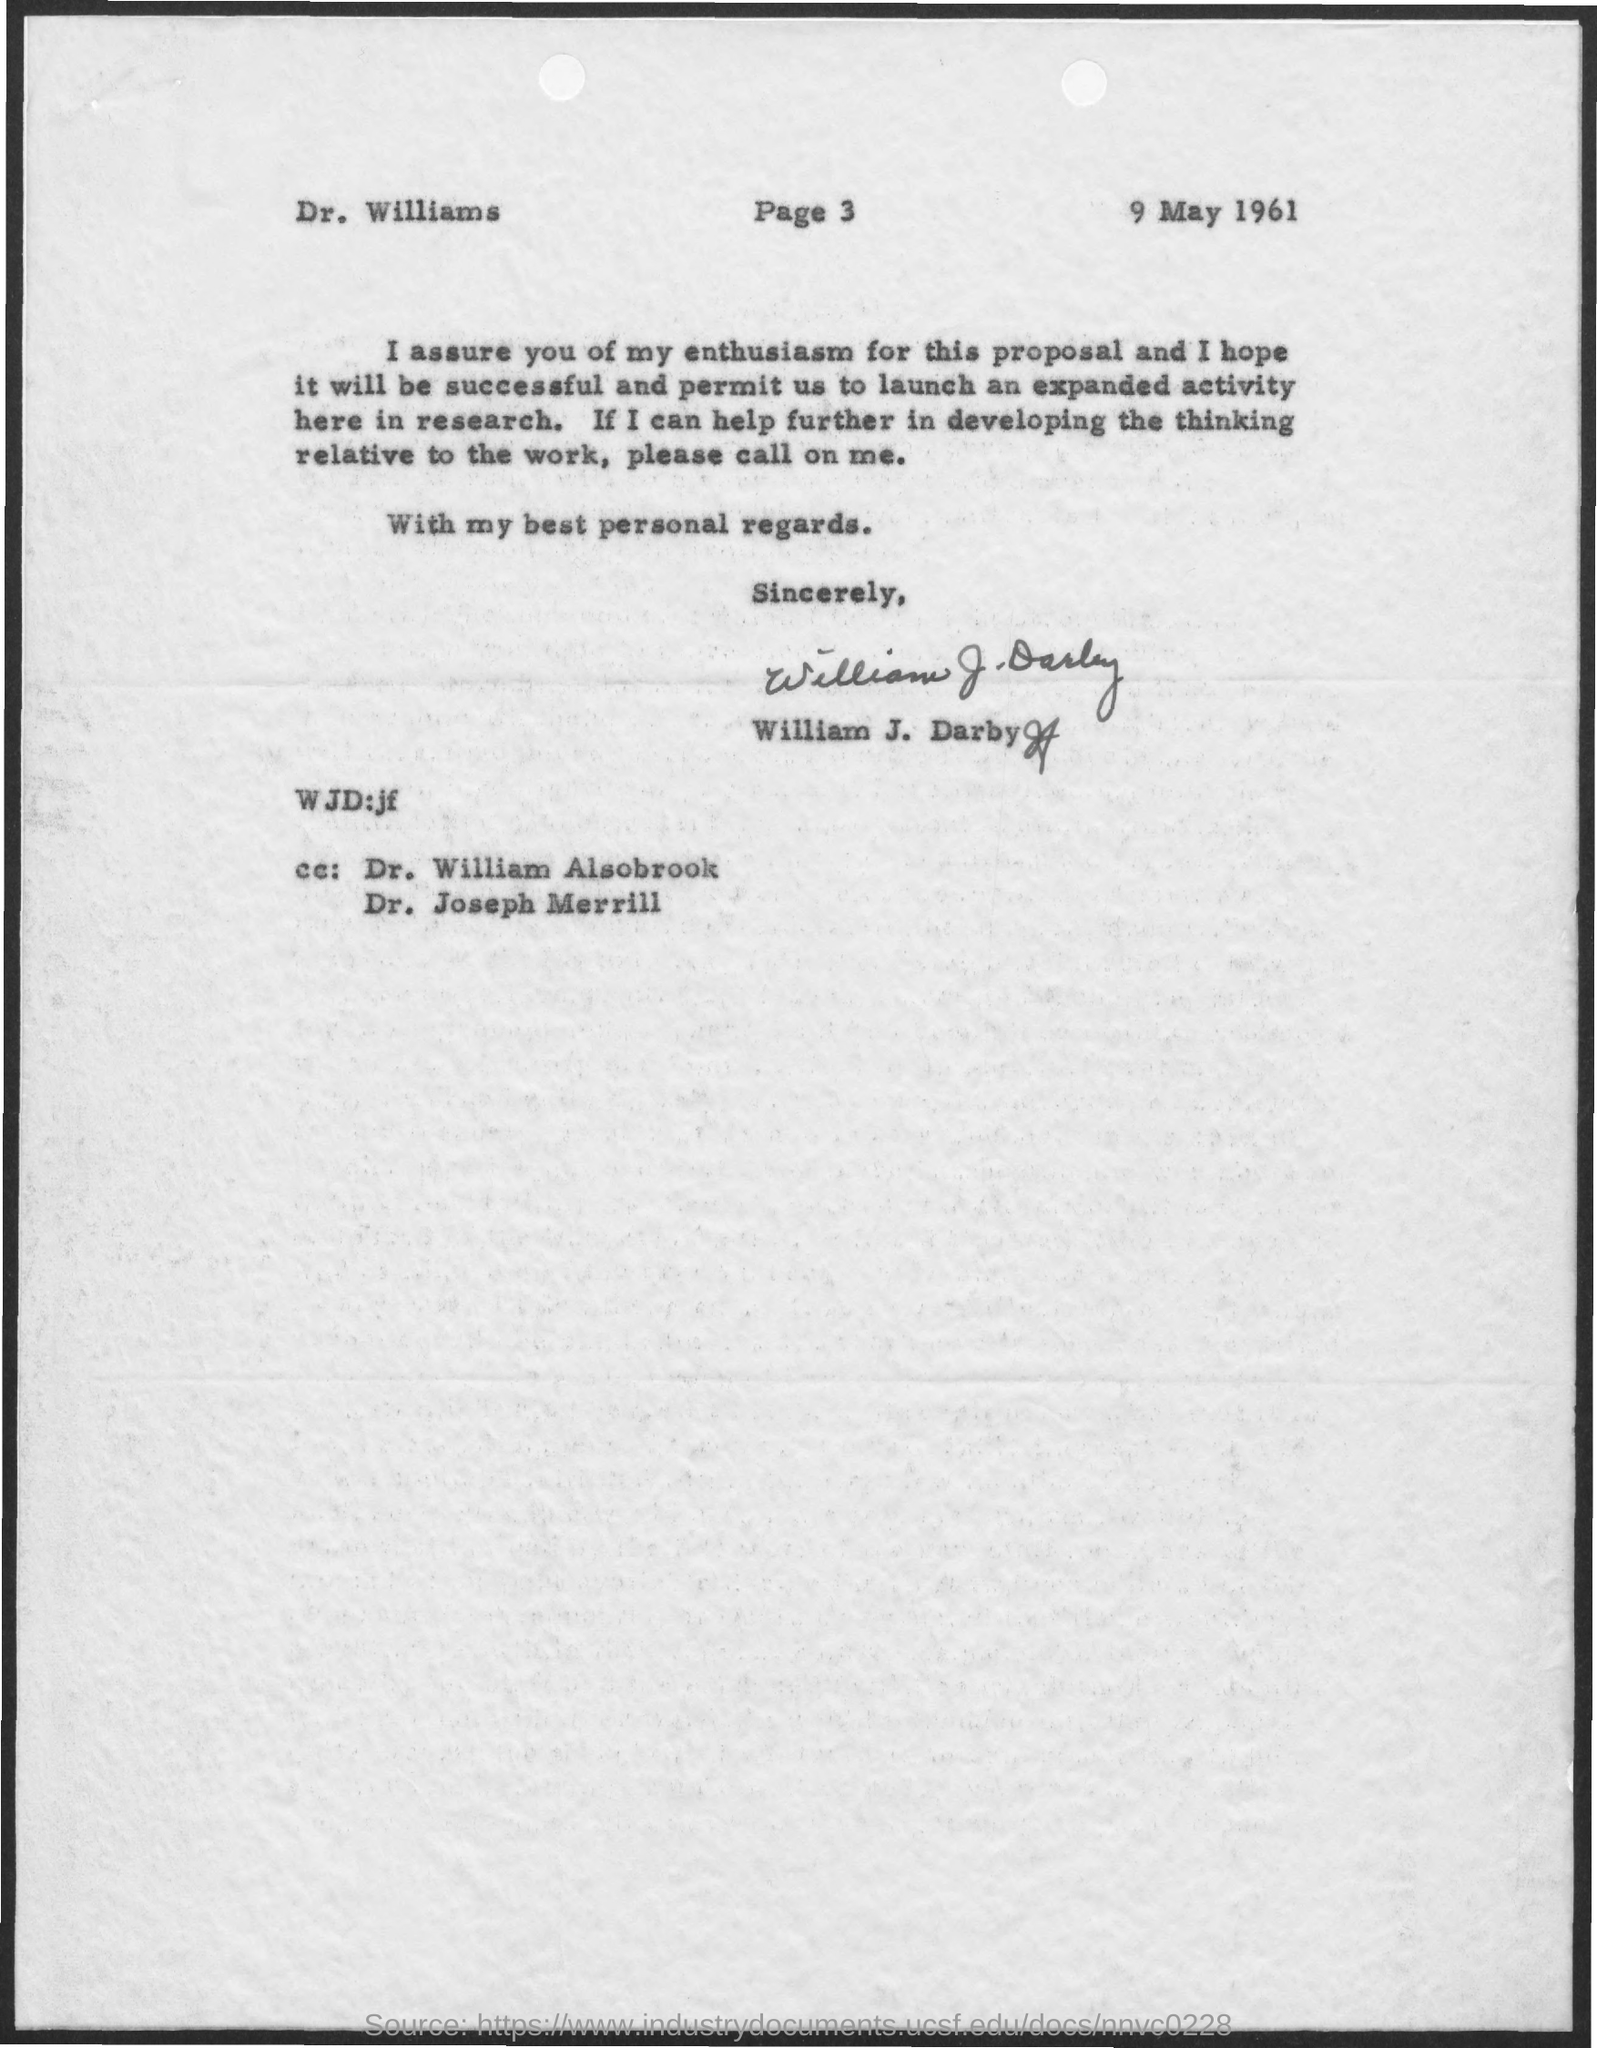To Whom is this letter addressed to?
Make the answer very short. Dr. williams. What is the date on the document?
Make the answer very short. 9 may 1961. Who is this letter from?
Make the answer very short. William J. Darby. 